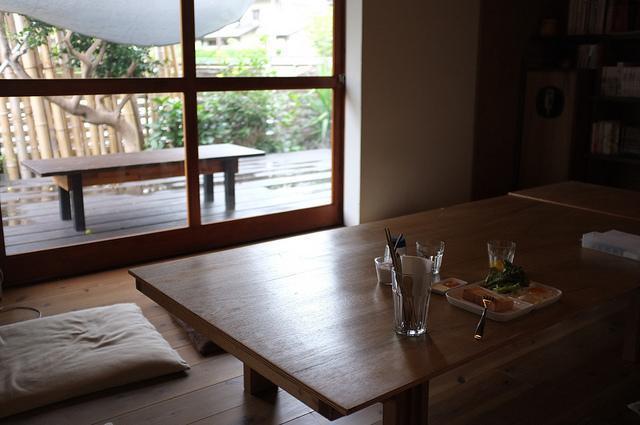What is closest to the left ledge of the table?
Select the accurate answer and provide explanation: 'Answer: answer
Rationale: rationale.'
Options: Pumpkin, orange, tray, glass. Answer: glass.
Rationale: The glass is on the left side of the table. 